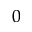Convert formula to latex. <formula><loc_0><loc_0><loc_500><loc_500>_ { 0 }</formula> 